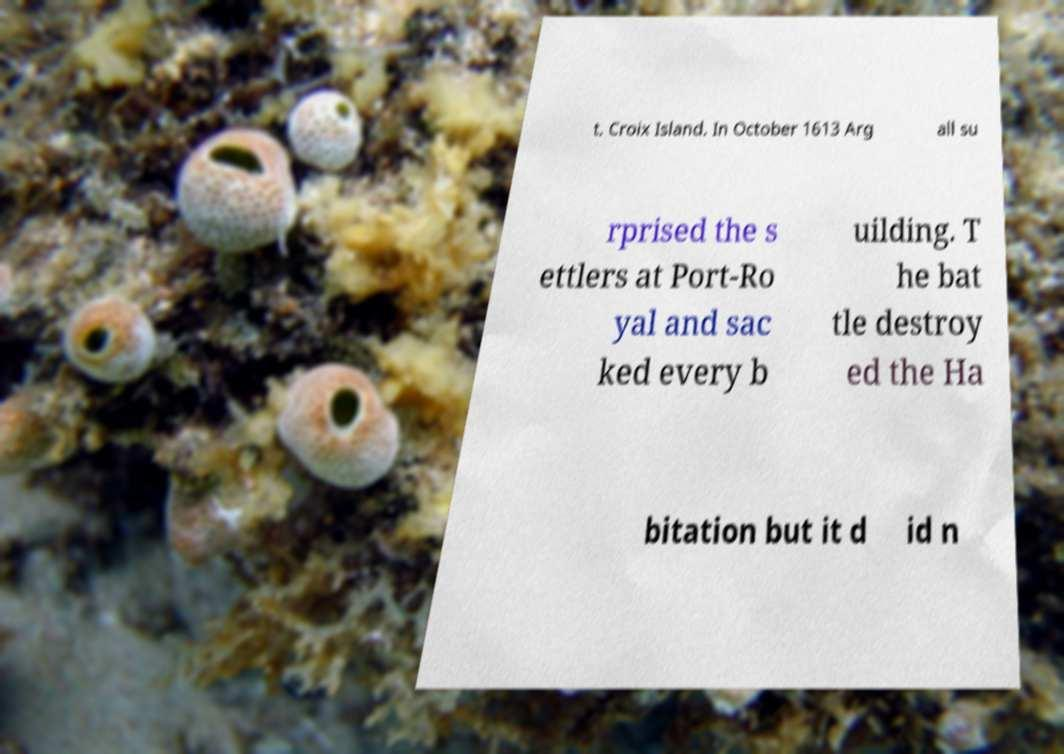Can you accurately transcribe the text from the provided image for me? t. Croix Island. In October 1613 Arg all su rprised the s ettlers at Port-Ro yal and sac ked every b uilding. T he bat tle destroy ed the Ha bitation but it d id n 